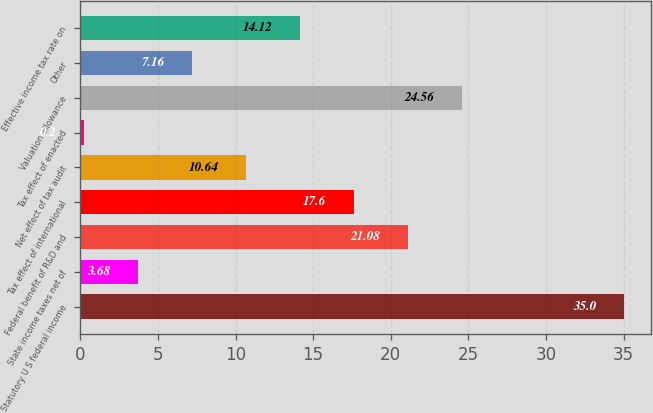Convert chart to OTSL. <chart><loc_0><loc_0><loc_500><loc_500><bar_chart><fcel>Statutory U S federal income<fcel>State income taxes net of<fcel>Federal benefit of R&D and<fcel>Tax effect of international<fcel>Net effect of tax audit<fcel>Tax effect of enacted<fcel>Valuation allowance<fcel>Other<fcel>Effective income tax rate on<nl><fcel>35<fcel>3.68<fcel>21.08<fcel>17.6<fcel>10.64<fcel>0.2<fcel>24.56<fcel>7.16<fcel>14.12<nl></chart> 